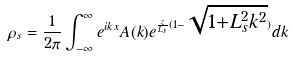Convert formula to latex. <formula><loc_0><loc_0><loc_500><loc_500>\rho _ { s } = \frac { 1 } { 2 \pi } \int _ { - \infty } ^ { \infty } e ^ { i k x } A ( k ) e ^ { \frac { z } { L _ { s } } ( 1 - \sqrt { 1 + L _ { s } ^ { 2 } k ^ { 2 } } ) } d k</formula> 